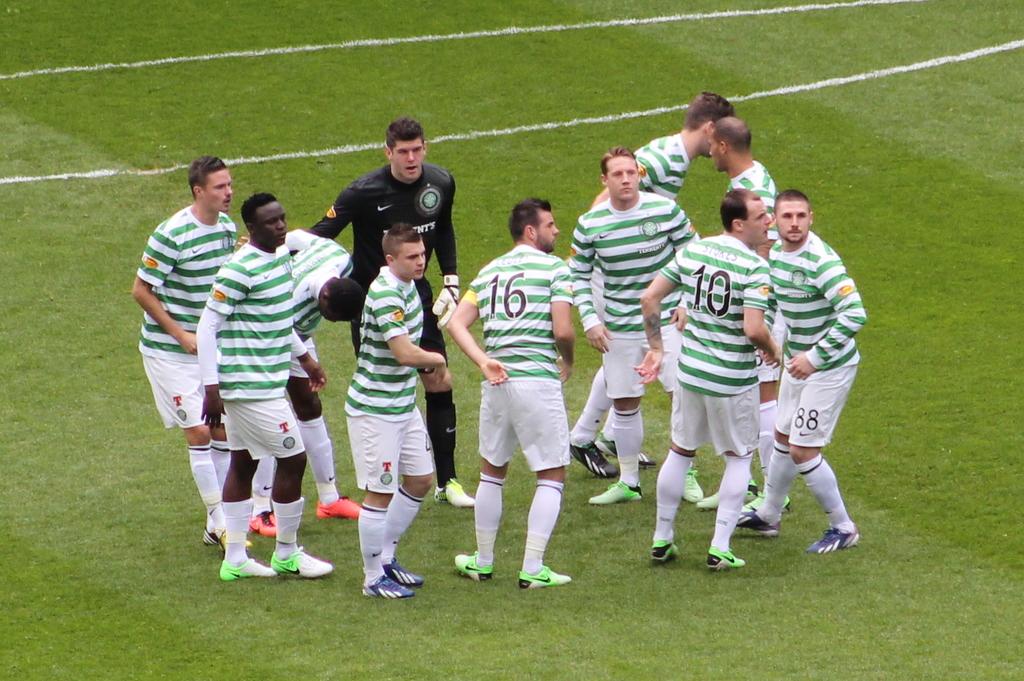What number is the man to the far right?
Offer a terse response. 88. What is the middle man's number?
Give a very brief answer. 16. 